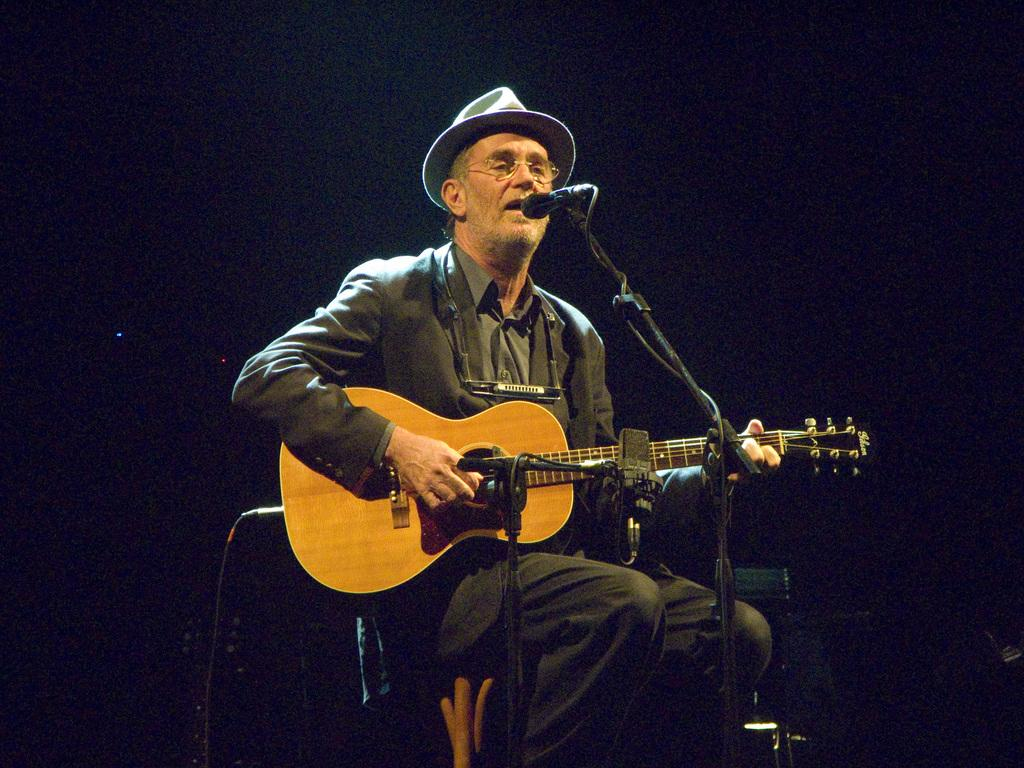Who is the main subject in the image? There is a man in the image. What is the man doing in the image? The man is sitting on a chair and playing the microphone in front of it. What object is the man holding in the image? The man is holding a microphone. What type of sock is the man wearing in the image? There is no mention of socks in the image, so it cannot be determined what type of sock the man is wearing. 